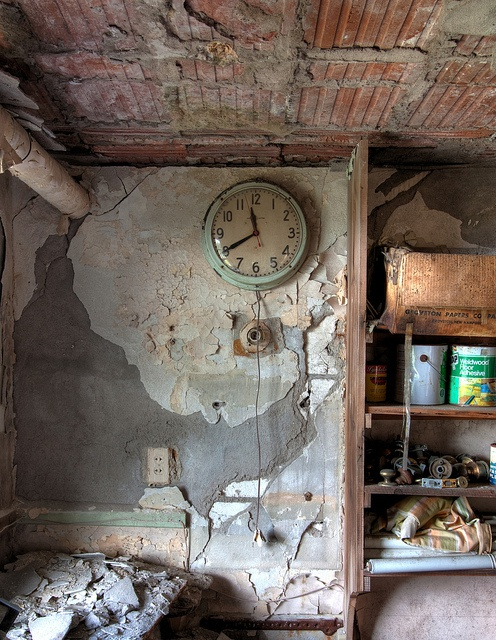Describe the objects in this image and their specific colors. I can see a clock in black and gray tones in this image. 